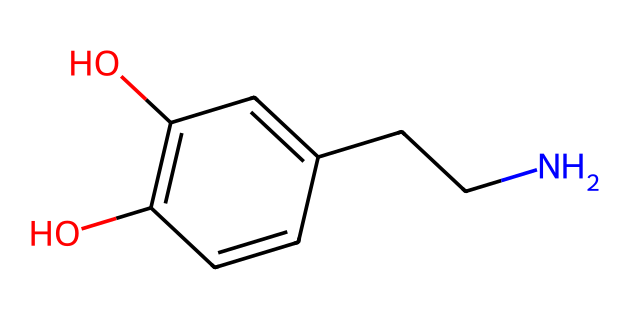What is the total number of carbon atoms in this compound? By analyzing the SMILES representation, we can count the number of carbon atoms represented by 'C'. In the given SMILES, there are six 'C' symbols, which indicate six carbon atoms in total.
Answer: 6 How many hydroxyl (–OH) groups are present in this structure? The presence of hydroxyl groups can be identified by looking for the 'O' followed by a hydrogen atom in the SMILES notation. There are two instances of 'O' that are part of -OH groups in the structure, indicating two hydroxyl groups.
Answer: 2 What is the molecular formula of this compound? To determine the molecular formula, we count the number of each type of atom: 9 carbons (C), 13 hydrogens (H), 2 oxygens (O), and 1 nitrogen (N). Therefore, the molecular formula is C9H13NO2.
Answer: C9H13NO2 What type of functional groups are present in this chemical? The compound contains hydroxyl (-OH) groups, indicated by the presence of oxygen connected to hydrogen in the SMILES; it also has an amine group (-NH) due to the presence of the nitrogen atom in the chain. These account for the key functional characteristics of this chemical.
Answer: hydroxyl and amine Does this compound have aromatic characteristics? Analyzing the structure, there are alternating double bonds and a benzene ring-like structure present, as indicated by the 'C=C' bonds in a cyclic arrangement. This confirms that the compound exhibits aromatic properties.
Answer: Yes 